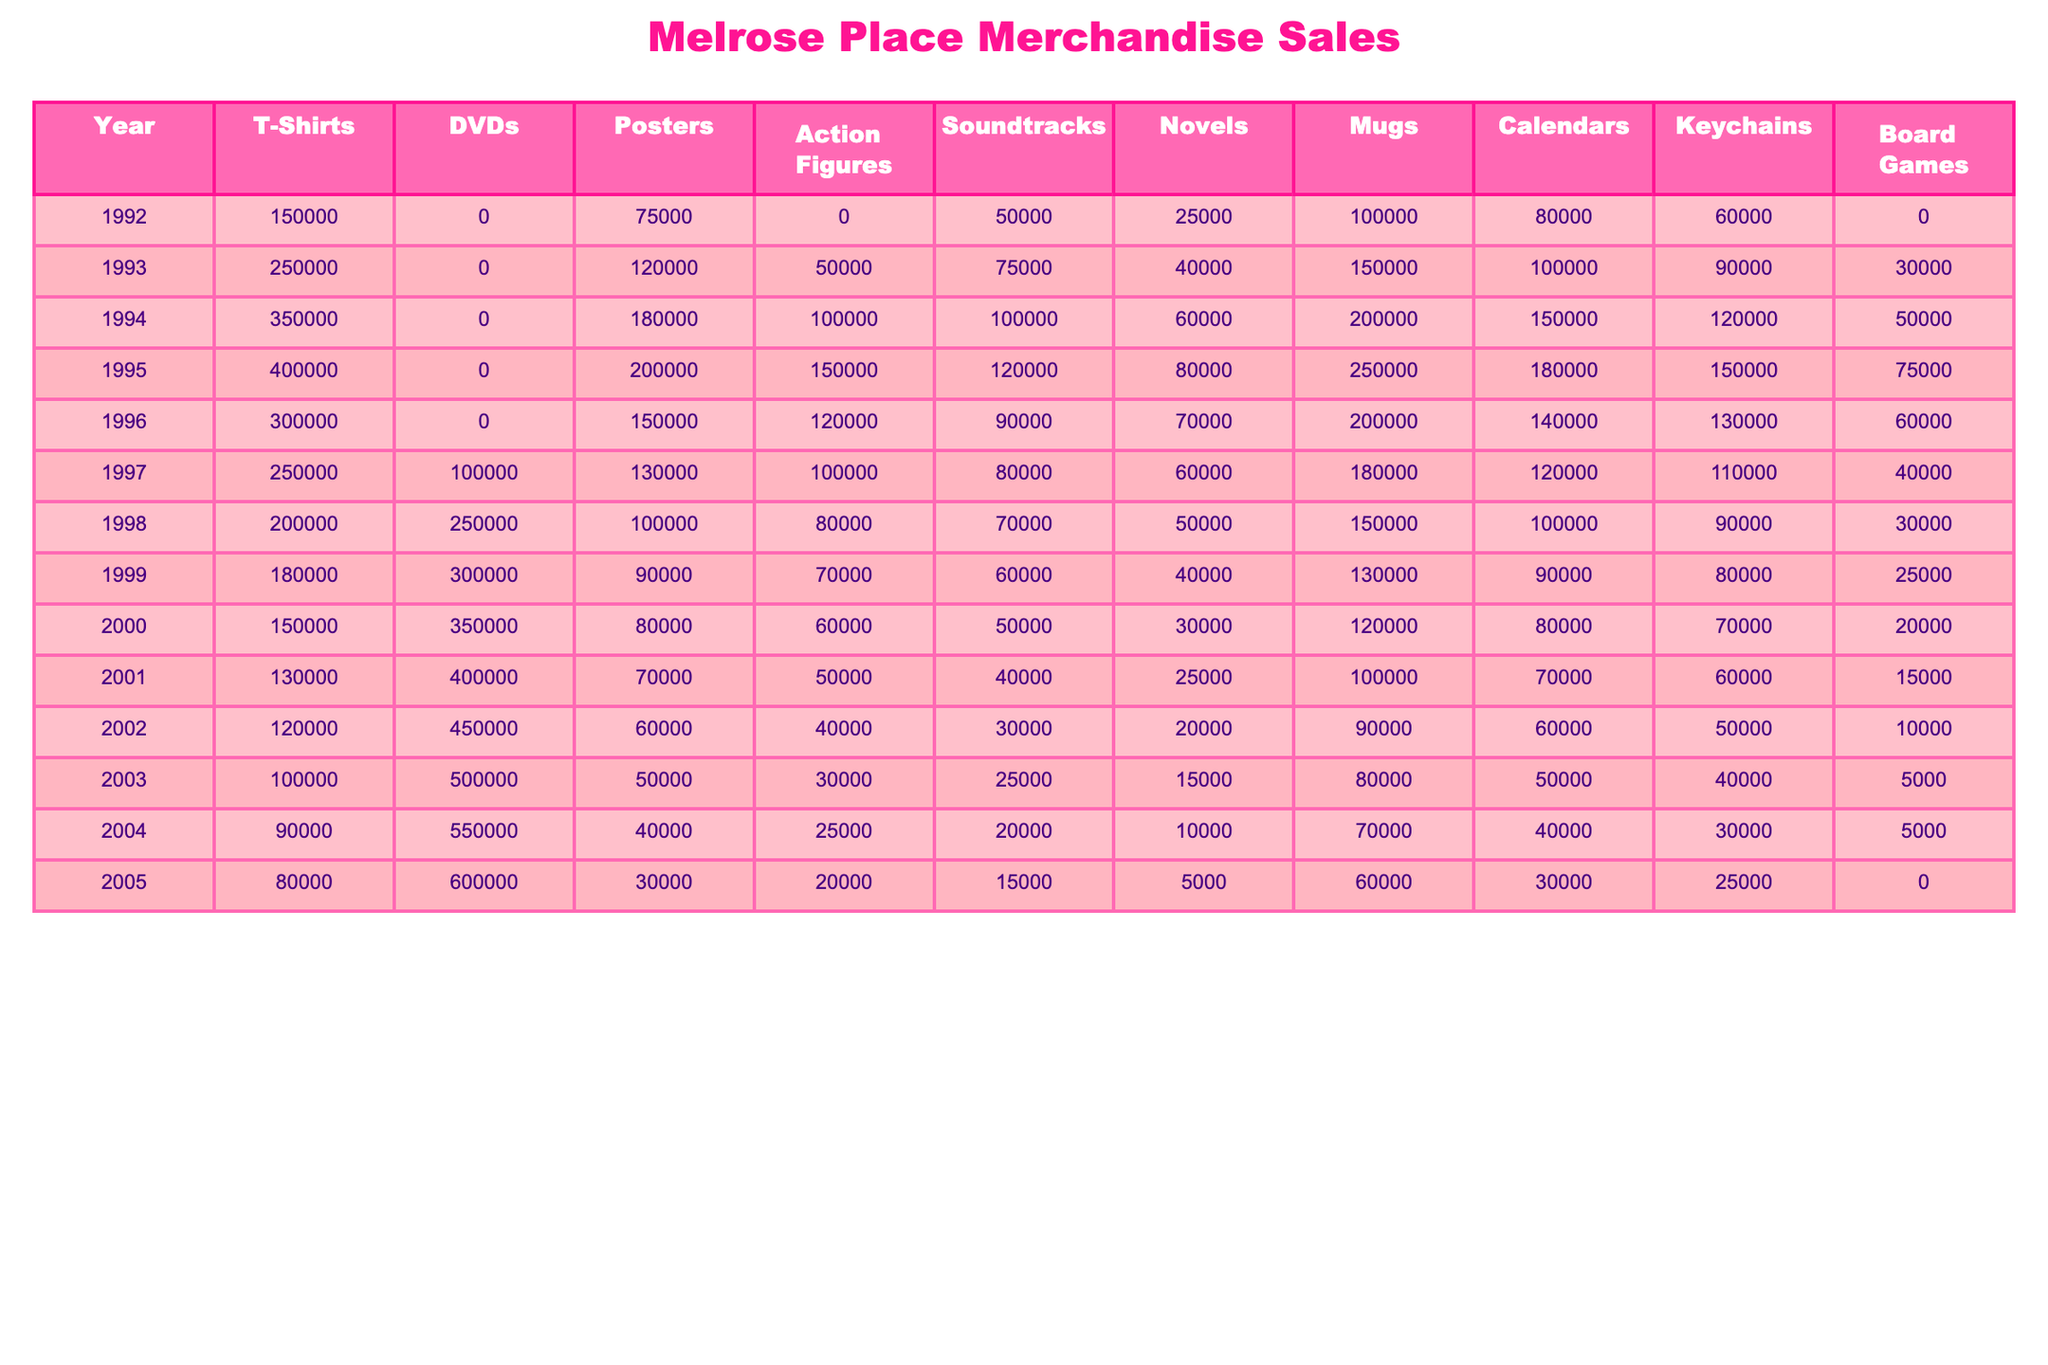What was the highest number of T-Shirts sold in a single year? The maximum value for T-Shirts in the table is 400,000 in 1995.
Answer: 400,000 Which year had the lowest sales of DVDs? The lowest sales for DVDs occurred in 1992, with 0 units sold.
Answer: 1992 What was the total number of posters sold across all years? By summing the values of the Posters column (75,000 + 120,000 + 180,000 + 200,000 + 150,000 + 130,000 + 100,000 + 90,000 + 80,000 + 70,000 + 60,000 + 40,000 + 30,000) results in a total of 1,320,000 posters sold.
Answer: 1,320,000 In what year did Action Figures sales reach 150,000? In 1995, Action Figures sales peaked at 150,000 units.
Answer: 1995 Did the sales of Soundtracks ever exceed 100,000 units in any year? Yes, there were four years where Soundtracks sales exceeded 100,000: 1994, 1995, 1996, and 1997.
Answer: Yes What was the difference in calendar sales between 1992 and 2005? Calendar sales in 1992 were 80,000 and in 2005 were 30,000, so the difference is 80,000 - 30,000 = 50,000.
Answer: 50,000 What was the average number of Mugs sold per year from 1992 to 2005? The average can be calculated by summing the Mugs column (100,000 + 150,000 + 200,000 + 250,000 + 200,000 + 180,000 + 150,000 + 120,000 + 90,000 + 60,000 + 30,000 + 5,000) which totals 1,575,000, divided by 14 (total years) equals approximately 112,500.
Answer: 112,500 What is the year with the highest sales of keychains? The highest sales of keychains occurred in 1995, with 150,000 units sold.
Answer: 1995 What product category had the lowest total sales over the entire period? Action Figures had the lowest total sales of 560,000 units over the entire period.
Answer: Action Figures What trend can be observed in DVD sales from 1998 to 2005? DVD sales steadily increased from 250,000 in 1998 to 600,000 in 2005, indicating a positive trend.
Answer: Increasing trend 